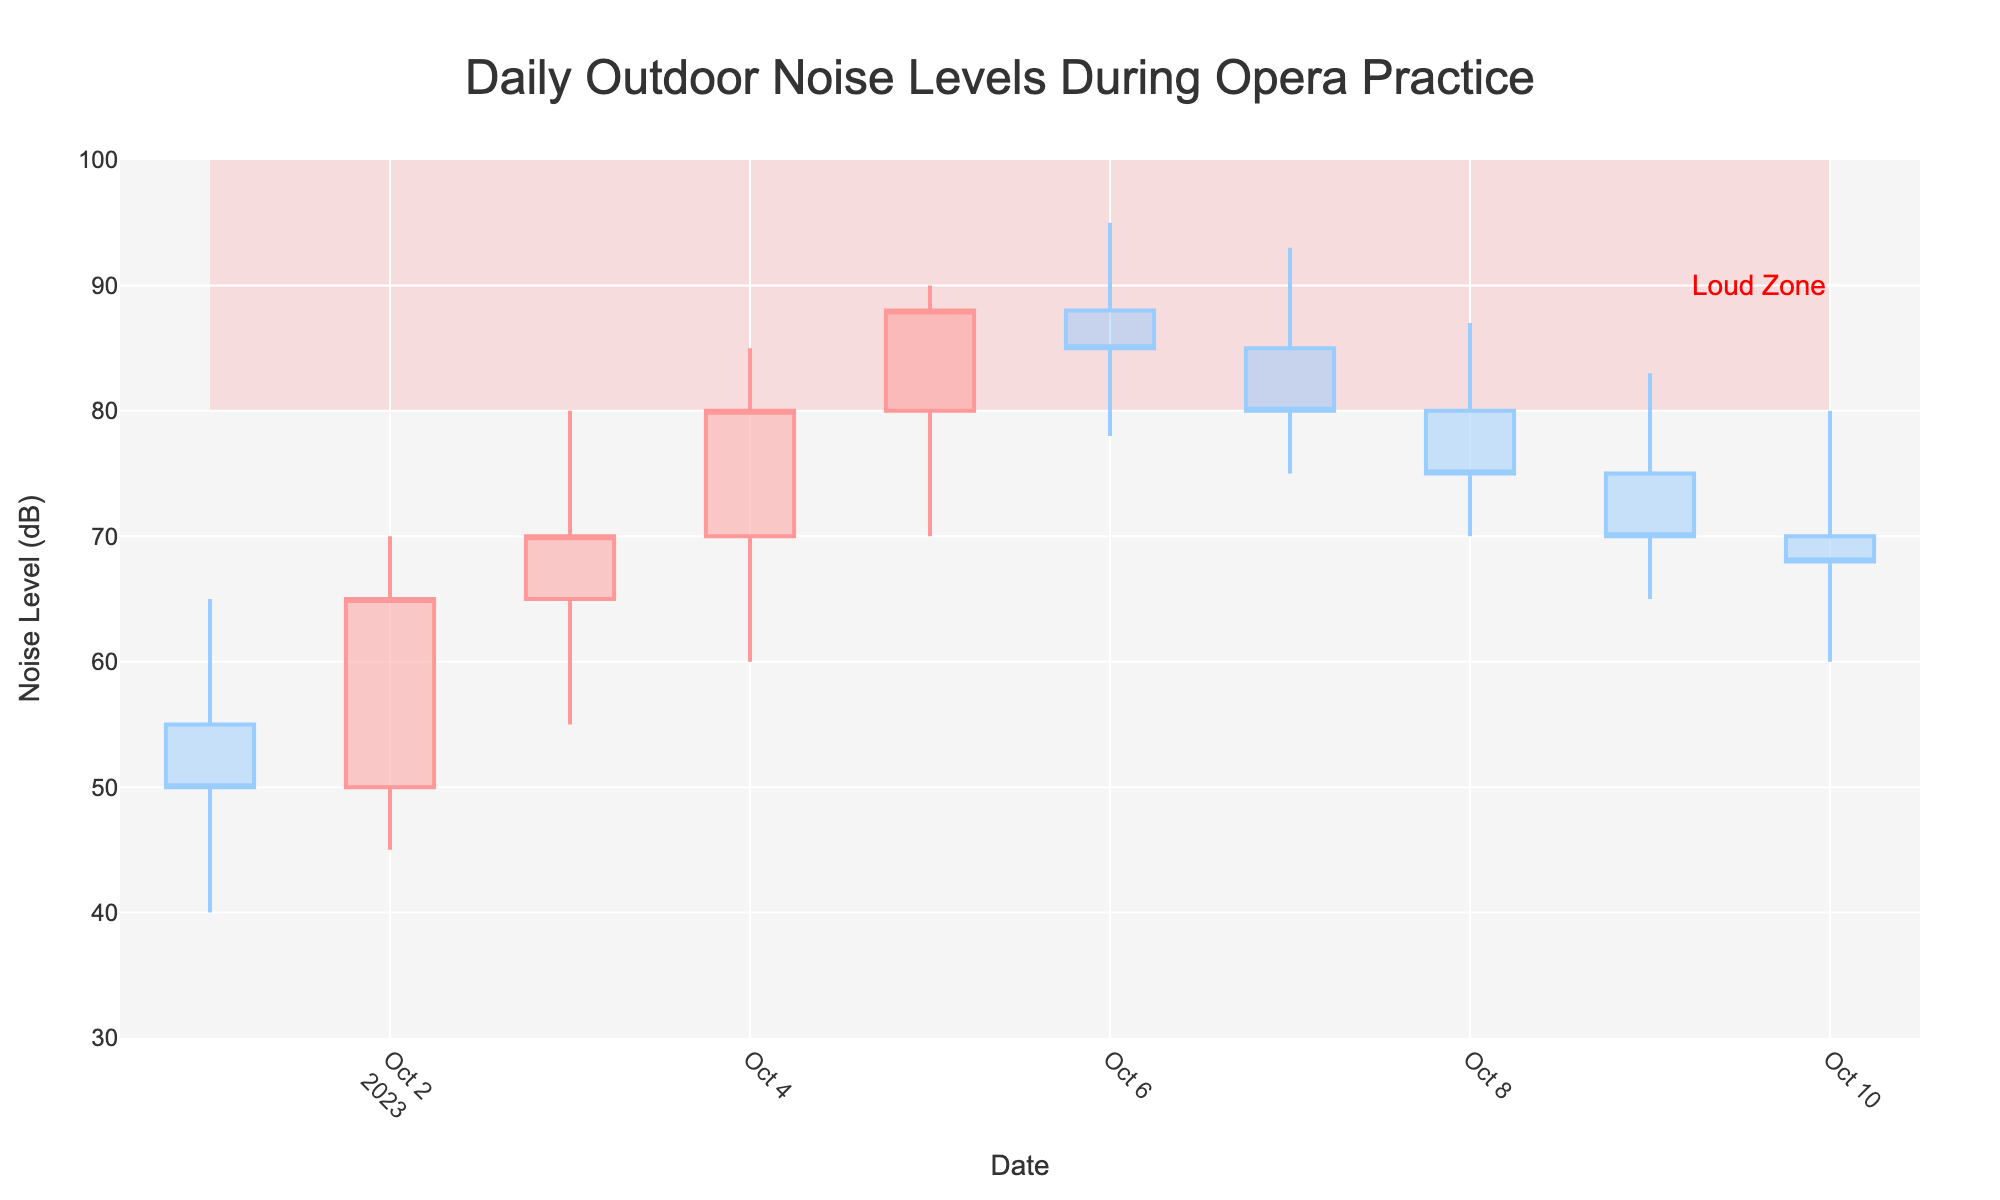What is the title of the plot? The title of the plot is stated at the top and is usually more prominent compared to other text in the plot.
Answer: Daily Outdoor Noise Levels During Opera Practice How many days' worth of noise data are represented in the plot? The x-axis represents the dates, and the range from October 1 to October 10 indicates the number of days included.
Answer: 10 days On which date was the highest noise level recorded? To find this, look at the highest point on the candlestick bars which represent noise levels. The highest value of 95 dB was recorded on October 6, 2023.
Answer: October 6, 2023 What is the "Loud Zone" in the plot? The "Loud Zone" is highlighted by a shaded area in the plot, typically labeled as such, which indicates noise levels between 80 dB and 100 dB.
Answer: Noise levels between 80 dB and 100 dB Which date had the largest difference between the High and Low noise levels? Calculate the difference between High and Low noise levels for each day and find the maximum. October 4, 2023, had the largest difference of 25 dB (85 - 60 dB).
Answer: October 4, 2023 How many days did the noise level end up (Close) higher than it started (Open)? Compare the Open and Close values for each day. The days are October 2, 3, 4, and 5 where the Close is higher than the Open.
Answer: 4 days What was the average closing noise level for the 10 days? Calculate the average by summing all the closing noise levels and dividing by the number of days: (50 + 65 + 70 + 80 + 88 + 85 + 80 + 75 + 70 + 68) / 10 = 73.1 dB.
Answer: 73.1 dB What was the trend of noise levels from October 1 to October 6? Observing the closing values from October 1 to October 6, there is an increasing trend as the noise levels rise from 50 dB to 85 dB before it starts to decrease on October 7.
Answer: Increasing Which day had noise levels that first entered the "Loud Zone"? Noise levels entered the "Loud Zone" on October 4, 2023, as indicated by the High value of 85 dB crossing the 80 dB threshold.
Answer: October 4, 2023 